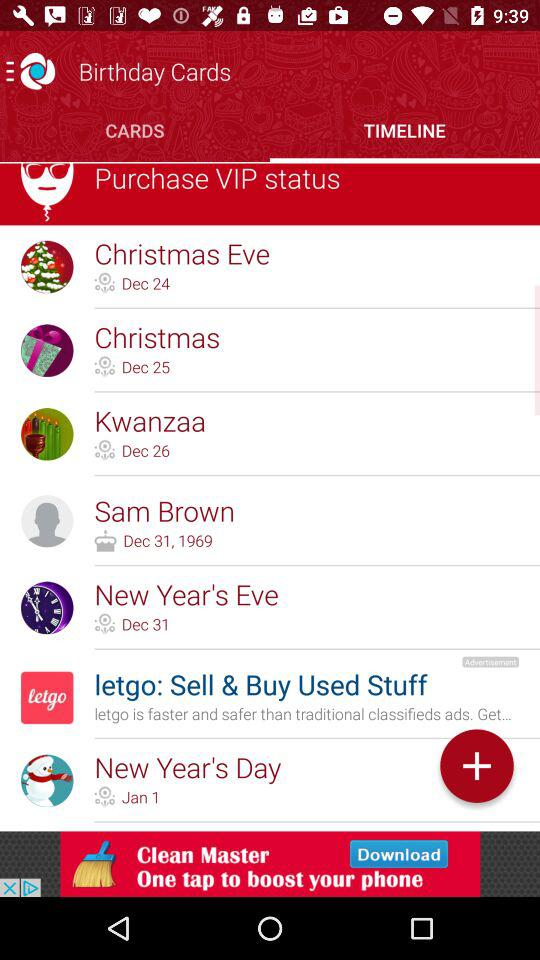Which is the selected tab? The selected tab is "TIMELINE". 